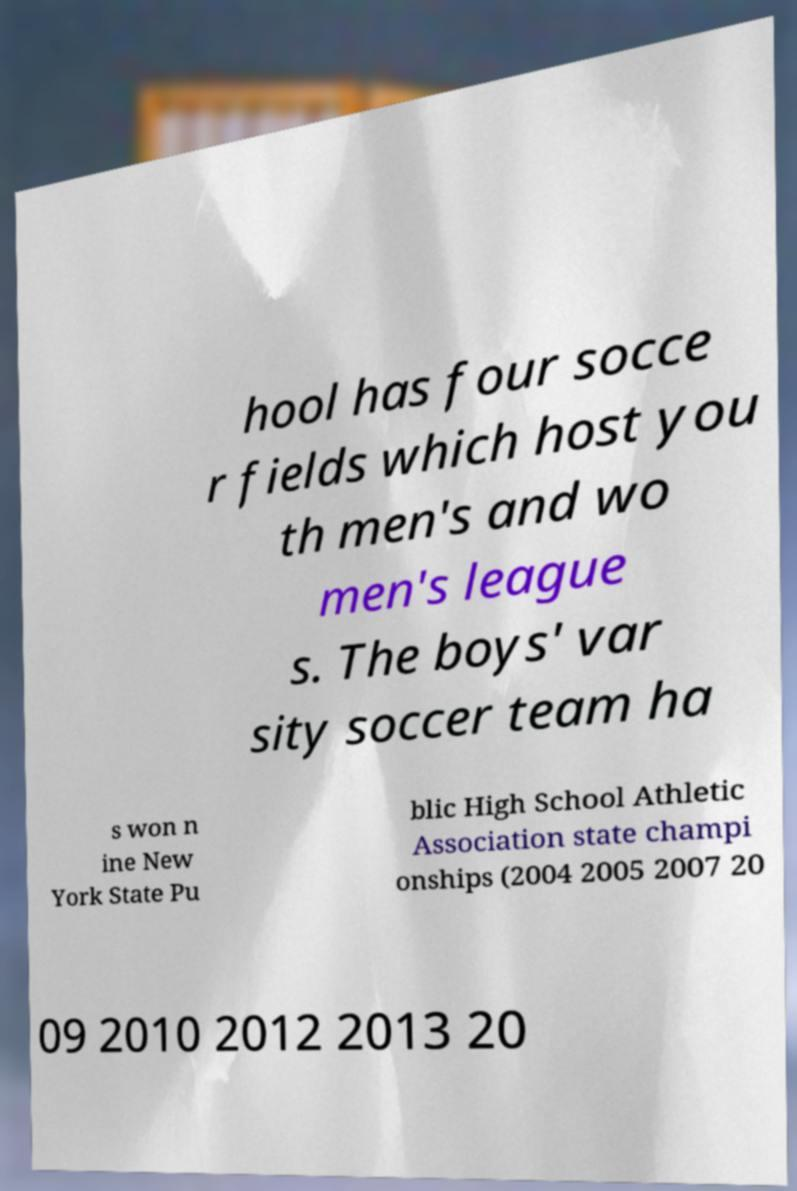There's text embedded in this image that I need extracted. Can you transcribe it verbatim? hool has four socce r fields which host you th men's and wo men's league s. The boys' var sity soccer team ha s won n ine New York State Pu blic High School Athletic Association state champi onships (2004 2005 2007 20 09 2010 2012 2013 20 